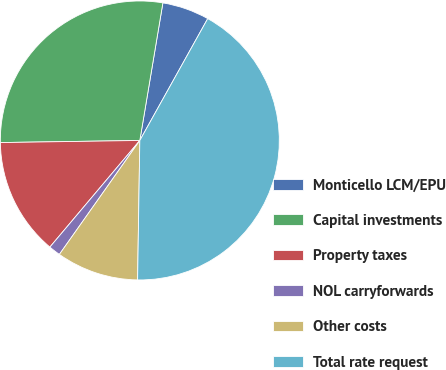Convert chart. <chart><loc_0><loc_0><loc_500><loc_500><pie_chart><fcel>Monticello LCM/EPU<fcel>Capital investments<fcel>Property taxes<fcel>NOL carryforwards<fcel>Other costs<fcel>Total rate request<nl><fcel>5.45%<fcel>27.89%<fcel>13.61%<fcel>1.37%<fcel>9.53%<fcel>42.17%<nl></chart> 